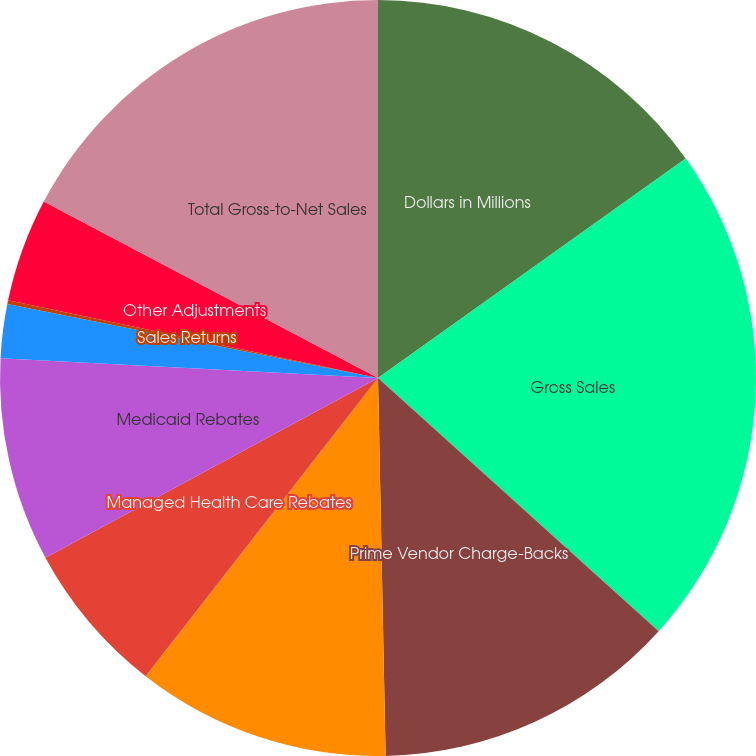Convert chart. <chart><loc_0><loc_0><loc_500><loc_500><pie_chart><fcel>Dollars in Millions<fcel>Gross Sales<fcel>Prime Vendor Charge-Backs<fcel>Women Infants and Children<fcel>Managed Health Care Rebates<fcel>Medicaid Rebates<fcel>Cash Discounts<fcel>Sales Returns<fcel>Other Adjustments<fcel>Total Gross-to-Net Sales<nl><fcel>15.14%<fcel>21.55%<fcel>13.0%<fcel>10.86%<fcel>6.58%<fcel>8.72%<fcel>2.3%<fcel>0.16%<fcel>4.44%<fcel>17.27%<nl></chart> 